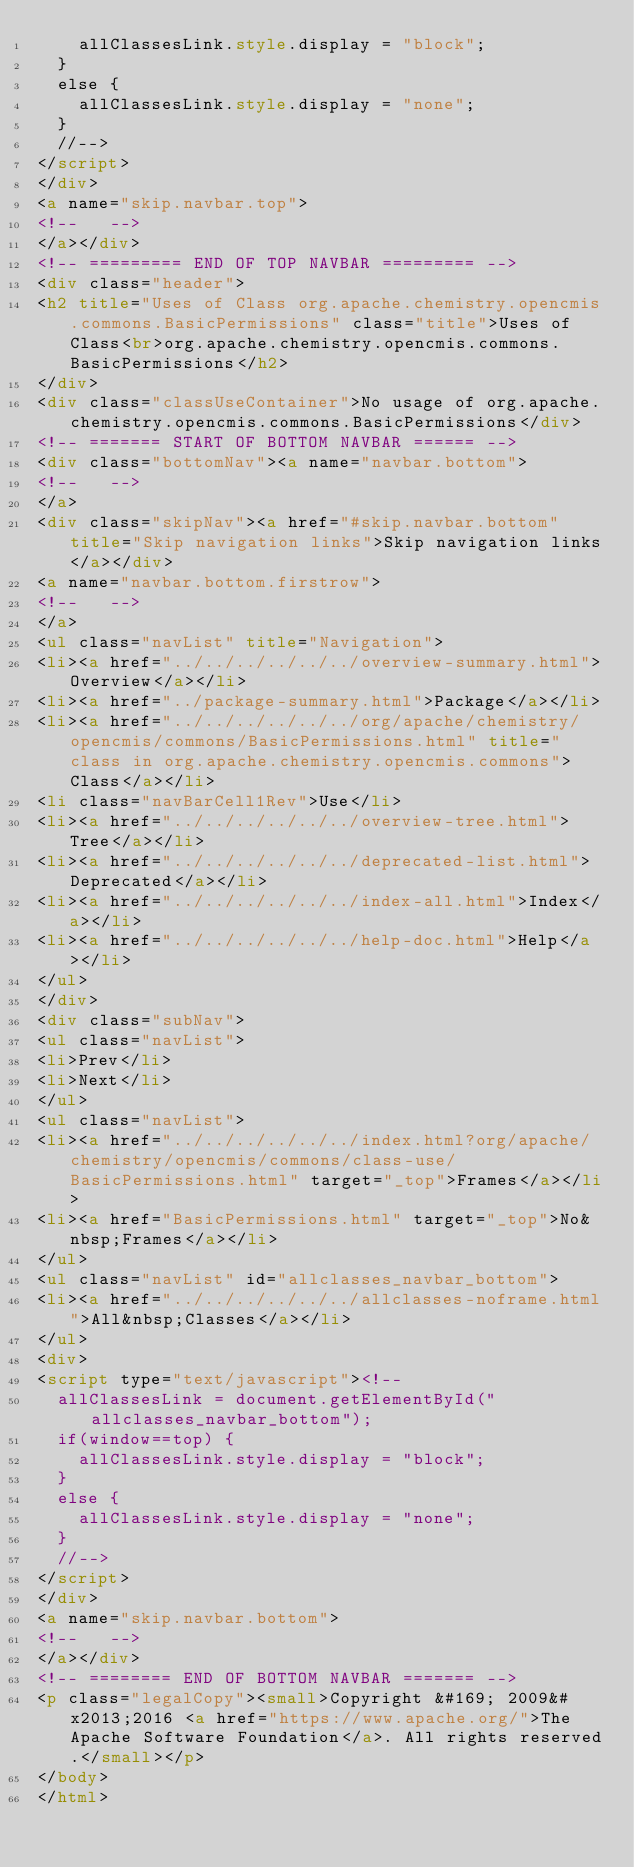Convert code to text. <code><loc_0><loc_0><loc_500><loc_500><_HTML_>    allClassesLink.style.display = "block";
  }
  else {
    allClassesLink.style.display = "none";
  }
  //-->
</script>
</div>
<a name="skip.navbar.top">
<!--   -->
</a></div>
<!-- ========= END OF TOP NAVBAR ========= -->
<div class="header">
<h2 title="Uses of Class org.apache.chemistry.opencmis.commons.BasicPermissions" class="title">Uses of Class<br>org.apache.chemistry.opencmis.commons.BasicPermissions</h2>
</div>
<div class="classUseContainer">No usage of org.apache.chemistry.opencmis.commons.BasicPermissions</div>
<!-- ======= START OF BOTTOM NAVBAR ====== -->
<div class="bottomNav"><a name="navbar.bottom">
<!--   -->
</a>
<div class="skipNav"><a href="#skip.navbar.bottom" title="Skip navigation links">Skip navigation links</a></div>
<a name="navbar.bottom.firstrow">
<!--   -->
</a>
<ul class="navList" title="Navigation">
<li><a href="../../../../../../overview-summary.html">Overview</a></li>
<li><a href="../package-summary.html">Package</a></li>
<li><a href="../../../../../../org/apache/chemistry/opencmis/commons/BasicPermissions.html" title="class in org.apache.chemistry.opencmis.commons">Class</a></li>
<li class="navBarCell1Rev">Use</li>
<li><a href="../../../../../../overview-tree.html">Tree</a></li>
<li><a href="../../../../../../deprecated-list.html">Deprecated</a></li>
<li><a href="../../../../../../index-all.html">Index</a></li>
<li><a href="../../../../../../help-doc.html">Help</a></li>
</ul>
</div>
<div class="subNav">
<ul class="navList">
<li>Prev</li>
<li>Next</li>
</ul>
<ul class="navList">
<li><a href="../../../../../../index.html?org/apache/chemistry/opencmis/commons/class-use/BasicPermissions.html" target="_top">Frames</a></li>
<li><a href="BasicPermissions.html" target="_top">No&nbsp;Frames</a></li>
</ul>
<ul class="navList" id="allclasses_navbar_bottom">
<li><a href="../../../../../../allclasses-noframe.html">All&nbsp;Classes</a></li>
</ul>
<div>
<script type="text/javascript"><!--
  allClassesLink = document.getElementById("allclasses_navbar_bottom");
  if(window==top) {
    allClassesLink.style.display = "block";
  }
  else {
    allClassesLink.style.display = "none";
  }
  //-->
</script>
</div>
<a name="skip.navbar.bottom">
<!--   -->
</a></div>
<!-- ======== END OF BOTTOM NAVBAR ======= -->
<p class="legalCopy"><small>Copyright &#169; 2009&#x2013;2016 <a href="https://www.apache.org/">The Apache Software Foundation</a>. All rights reserved.</small></p>
</body>
</html>
</code> 